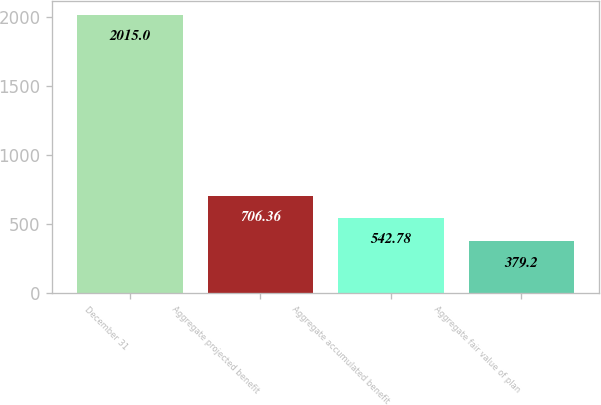Convert chart to OTSL. <chart><loc_0><loc_0><loc_500><loc_500><bar_chart><fcel>December 31<fcel>Aggregate projected benefit<fcel>Aggregate accumulated benefit<fcel>Aggregate fair value of plan<nl><fcel>2015<fcel>706.36<fcel>542.78<fcel>379.2<nl></chart> 